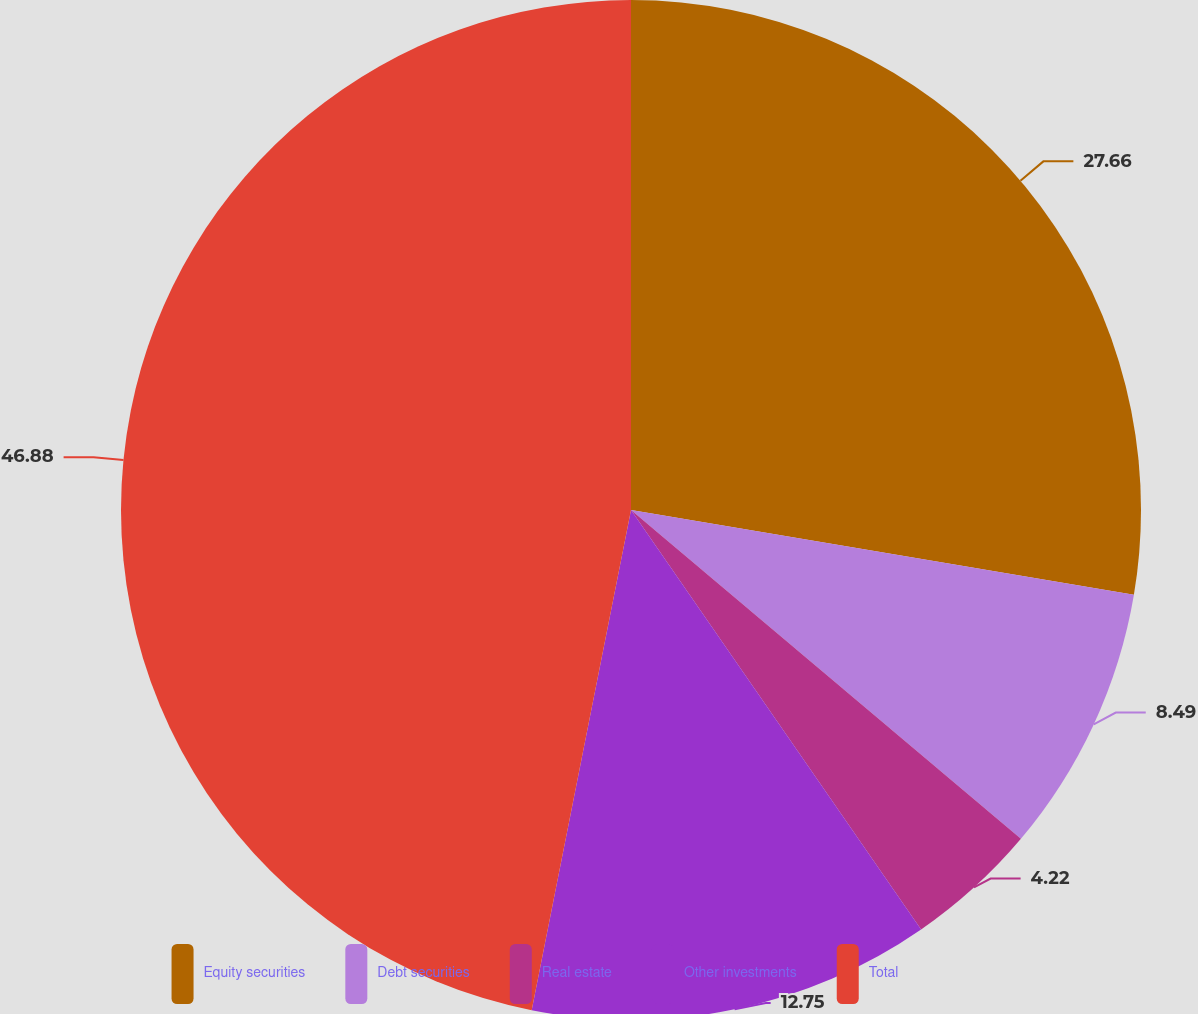<chart> <loc_0><loc_0><loc_500><loc_500><pie_chart><fcel>Equity securities<fcel>Debt securities<fcel>Real estate<fcel>Other investments<fcel>Total<nl><fcel>27.66%<fcel>8.49%<fcel>4.22%<fcel>12.75%<fcel>46.88%<nl></chart> 